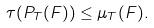<formula> <loc_0><loc_0><loc_500><loc_500>\tau ( P _ { T } ( F ) ) \leq \mu _ { T } ( F ) .</formula> 